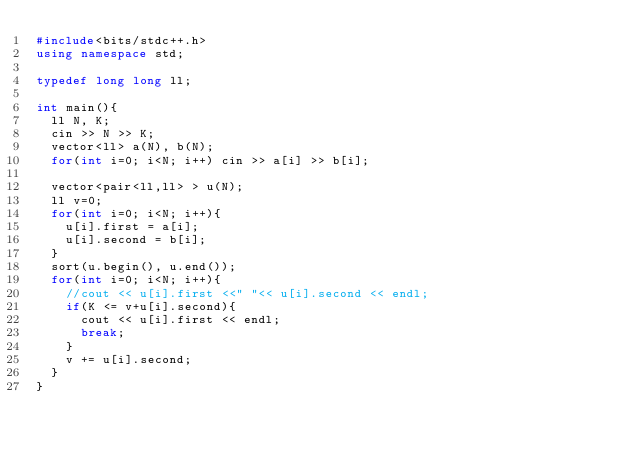Convert code to text. <code><loc_0><loc_0><loc_500><loc_500><_C++_>#include<bits/stdc++.h>
using namespace std;

typedef long long ll;

int main(){
  ll N, K;
  cin >> N >> K;
  vector<ll> a(N), b(N);
  for(int i=0; i<N; i++) cin >> a[i] >> b[i];

  vector<pair<ll,ll> > u(N);
  ll v=0;
  for(int i=0; i<N; i++){
    u[i].first = a[i];
    u[i].second = b[i];
  }
  sort(u.begin(), u.end());
  for(int i=0; i<N; i++){
    //cout << u[i].first <<" "<< u[i].second << endl;
    if(K <= v+u[i].second){
      cout << u[i].first << endl;
      break;
    }
    v += u[i].second;
  }
}
</code> 